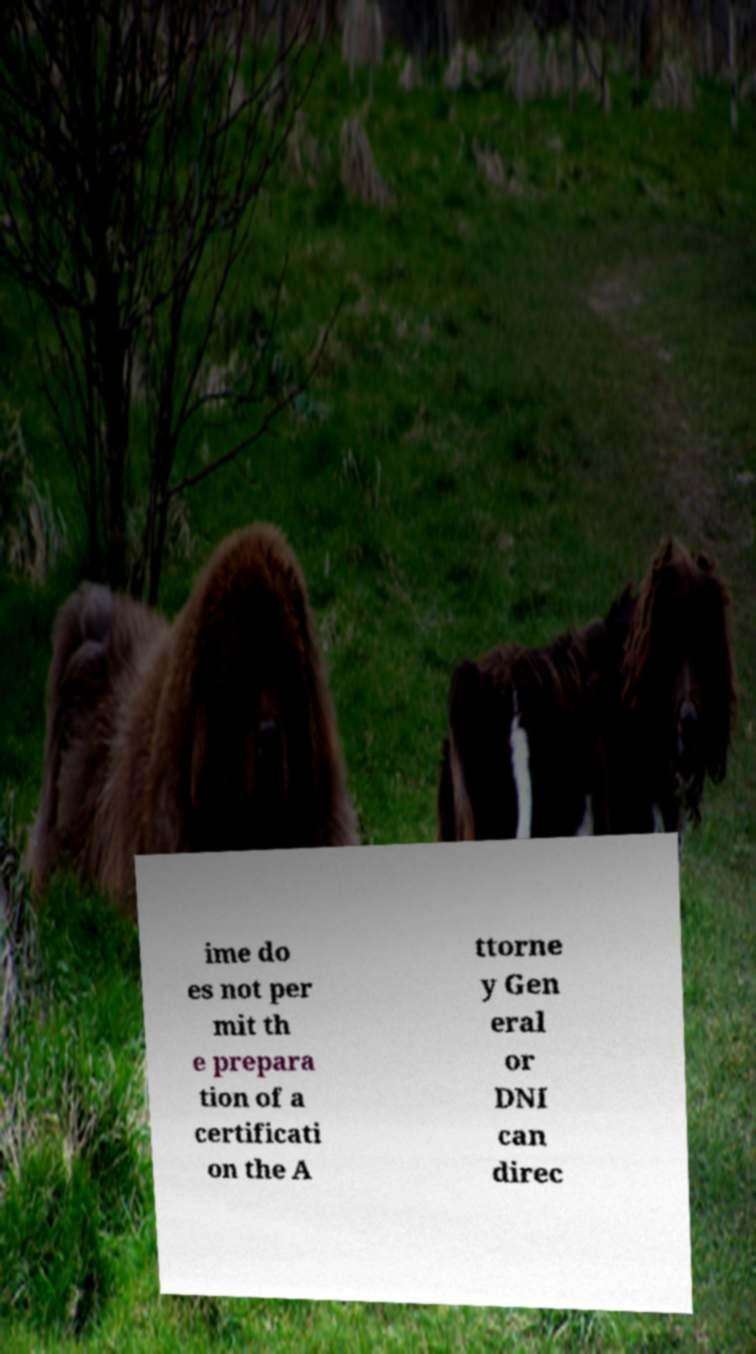Could you extract and type out the text from this image? ime do es not per mit th e prepara tion of a certificati on the A ttorne y Gen eral or DNI can direc 